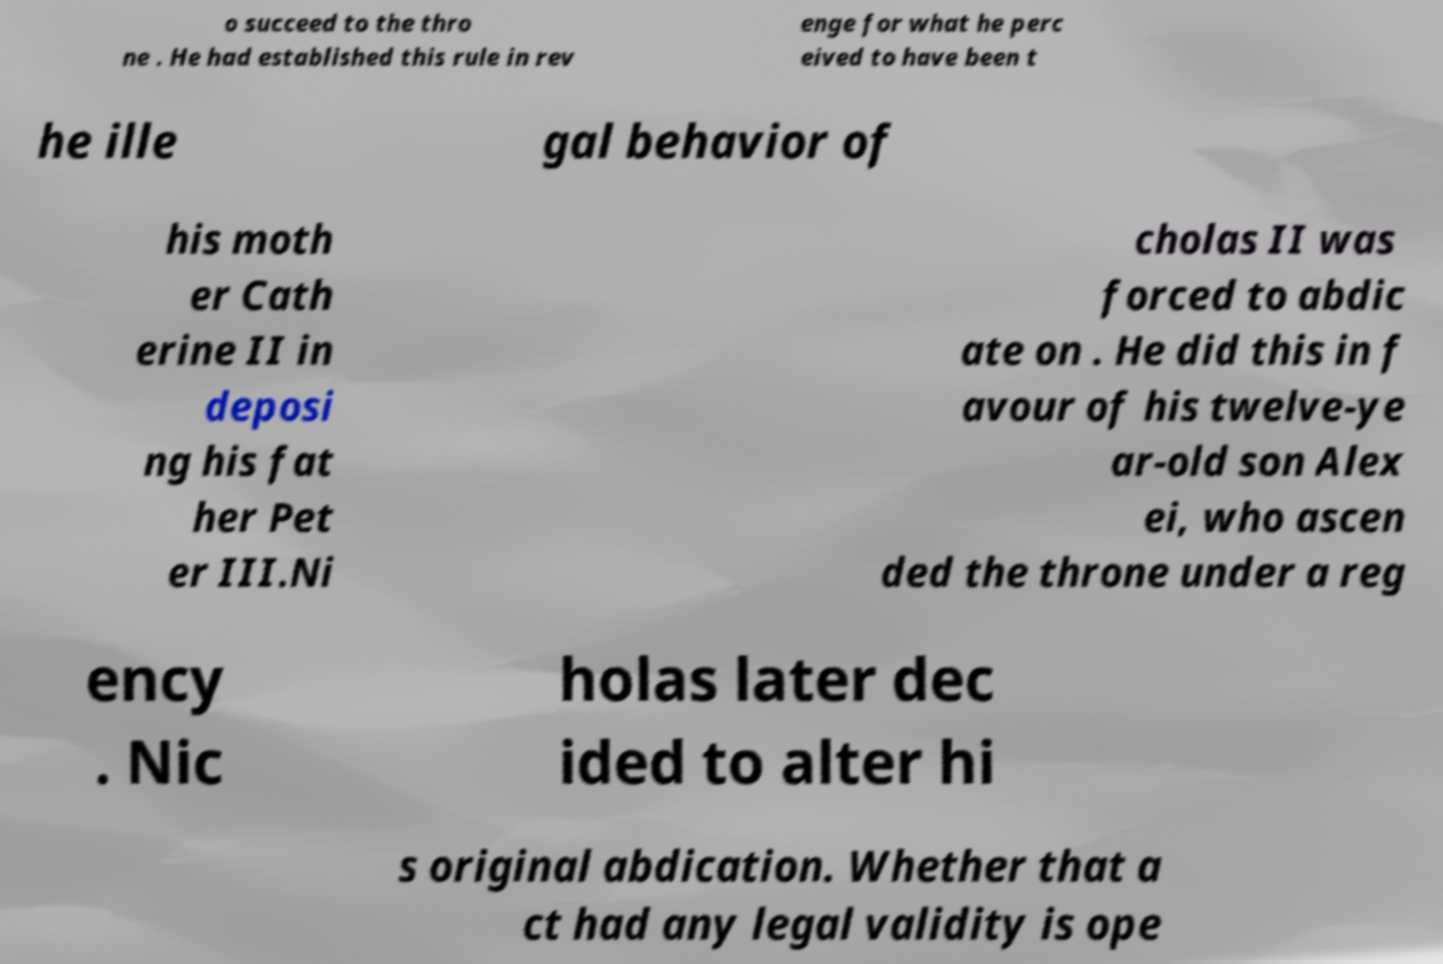Could you assist in decoding the text presented in this image and type it out clearly? o succeed to the thro ne . He had established this rule in rev enge for what he perc eived to have been t he ille gal behavior of his moth er Cath erine II in deposi ng his fat her Pet er III.Ni cholas II was forced to abdic ate on . He did this in f avour of his twelve-ye ar-old son Alex ei, who ascen ded the throne under a reg ency . Nic holas later dec ided to alter hi s original abdication. Whether that a ct had any legal validity is ope 